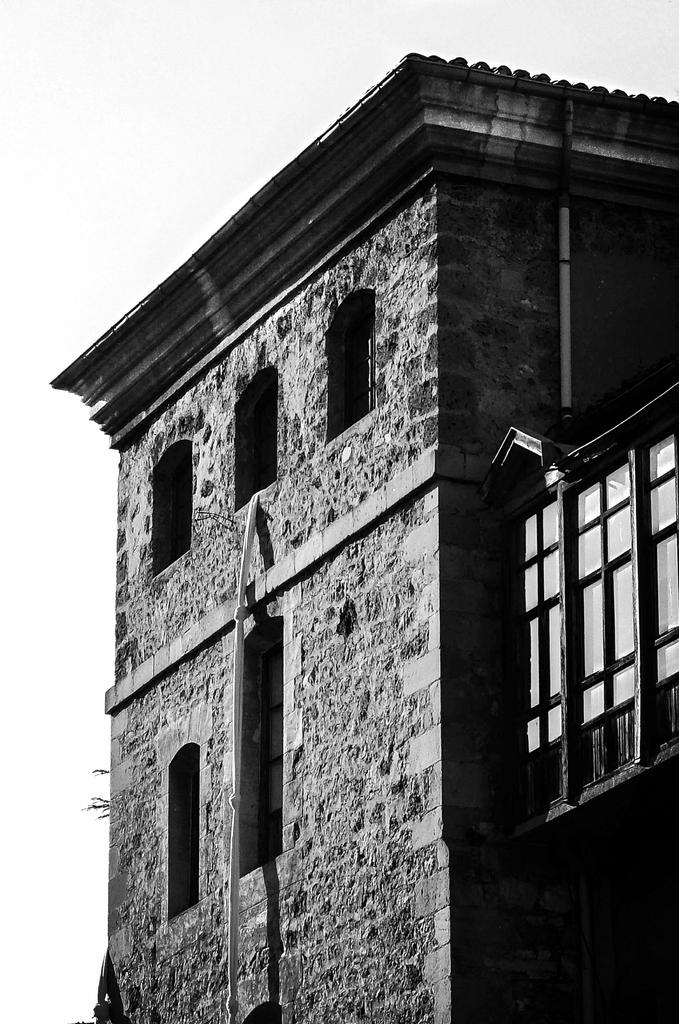What is the main structure in the picture? There is a building in the picture. Can you describe any specific features of the building? Yes, there are glass windows in the right corner of the building. How many steps does the beginner need to take to reach the balloon in the picture? There is no balloon present in the picture, so it is not possible to answer that question. 